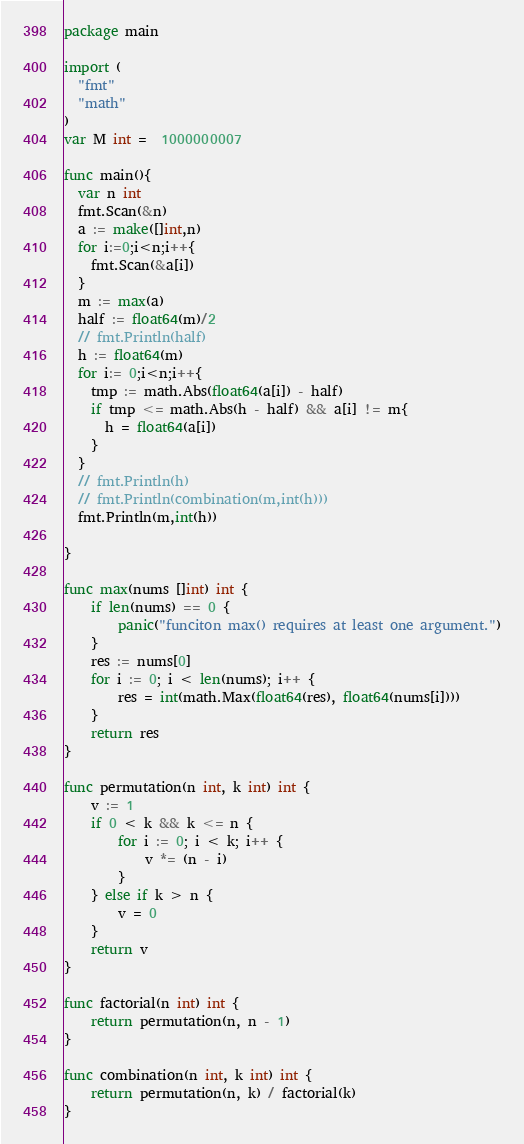Convert code to text. <code><loc_0><loc_0><loc_500><loc_500><_Go_>package main

import (
  "fmt"
  "math"
)
var M int =  1000000007

func main(){
  var n int
  fmt.Scan(&n)
  a := make([]int,n)
  for i:=0;i<n;i++{
    fmt.Scan(&a[i])
  }
  m := max(a)
  half := float64(m)/2
  // fmt.Println(half)
  h := float64(m)
  for i:= 0;i<n;i++{
    tmp := math.Abs(float64(a[i]) - half)
    if tmp <= math.Abs(h - half) && a[i] != m{
      h = float64(a[i])
    }
  }
  // fmt.Println(h)
  // fmt.Println(combination(m,int(h)))
  fmt.Println(m,int(h))

}

func max(nums []int) int {
    if len(nums) == 0 {
        panic("funciton max() requires at least one argument.")
    }
    res := nums[0]
    for i := 0; i < len(nums); i++ {
        res = int(math.Max(float64(res), float64(nums[i])))
    }
    return res
}

func permutation(n int, k int) int {
    v := 1
    if 0 < k && k <= n {
        for i := 0; i < k; i++ {
            v *= (n - i)
        }
    } else if k > n {
        v = 0
    }
    return v
}

func factorial(n int) int {
    return permutation(n, n - 1)
}

func combination(n int, k int) int {
    return permutation(n, k) / factorial(k)
}
</code> 